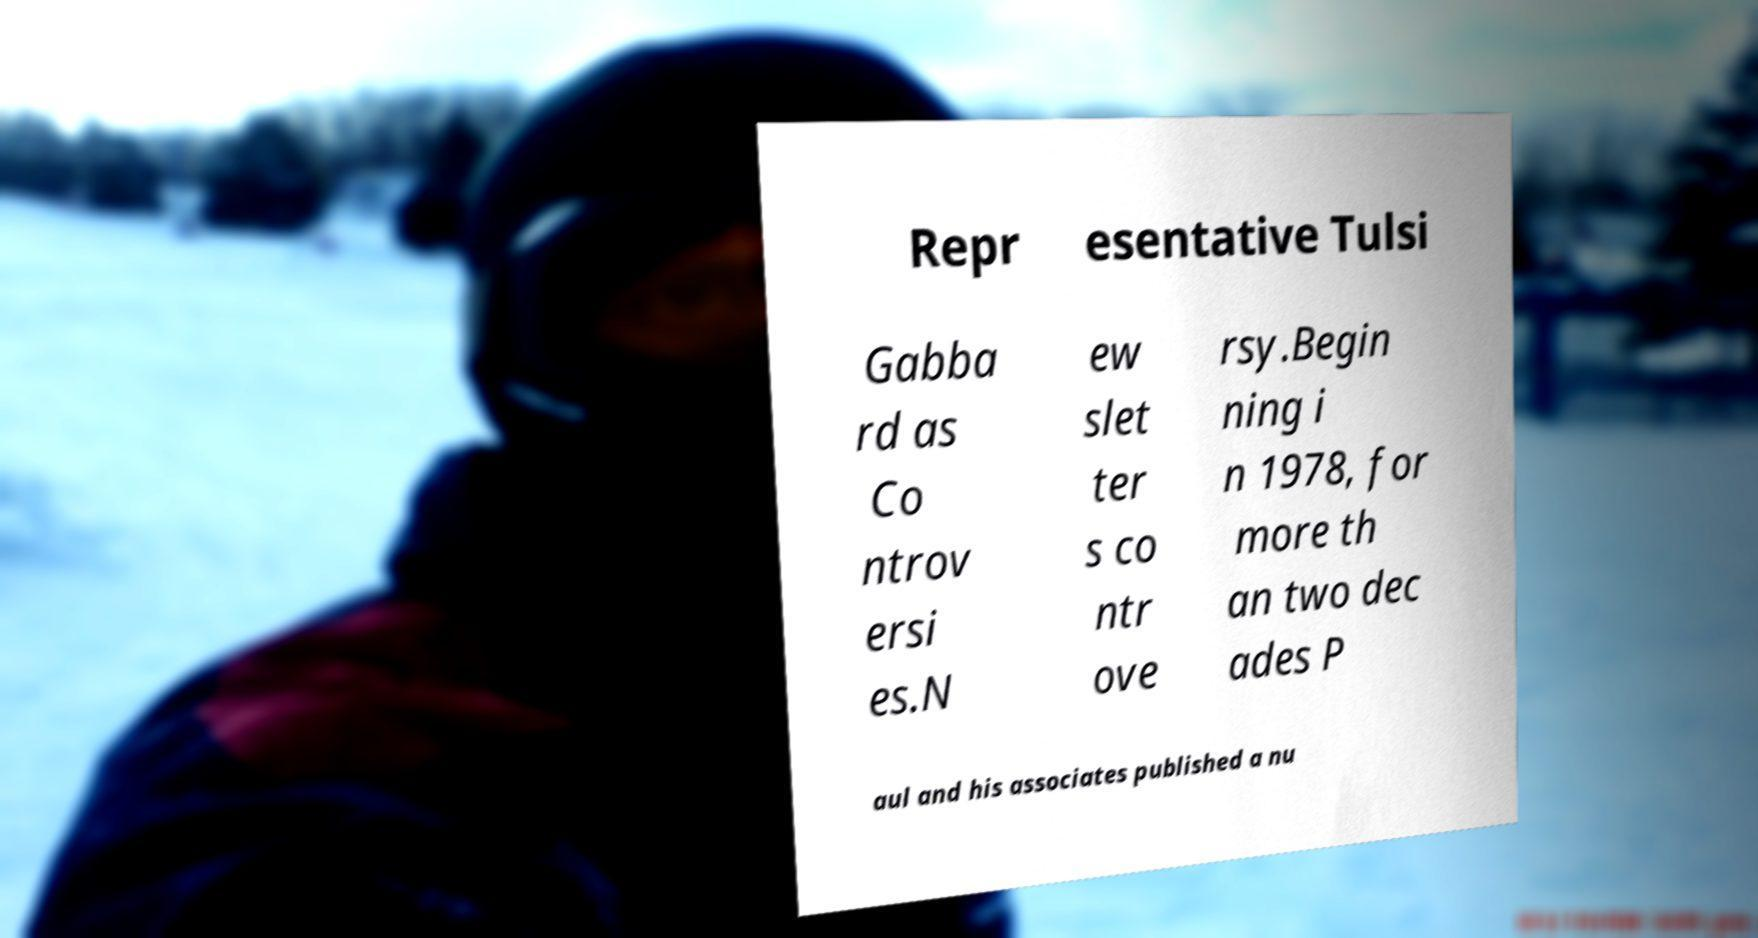Please identify and transcribe the text found in this image. Repr esentative Tulsi Gabba rd as Co ntrov ersi es.N ew slet ter s co ntr ove rsy.Begin ning i n 1978, for more th an two dec ades P aul and his associates published a nu 